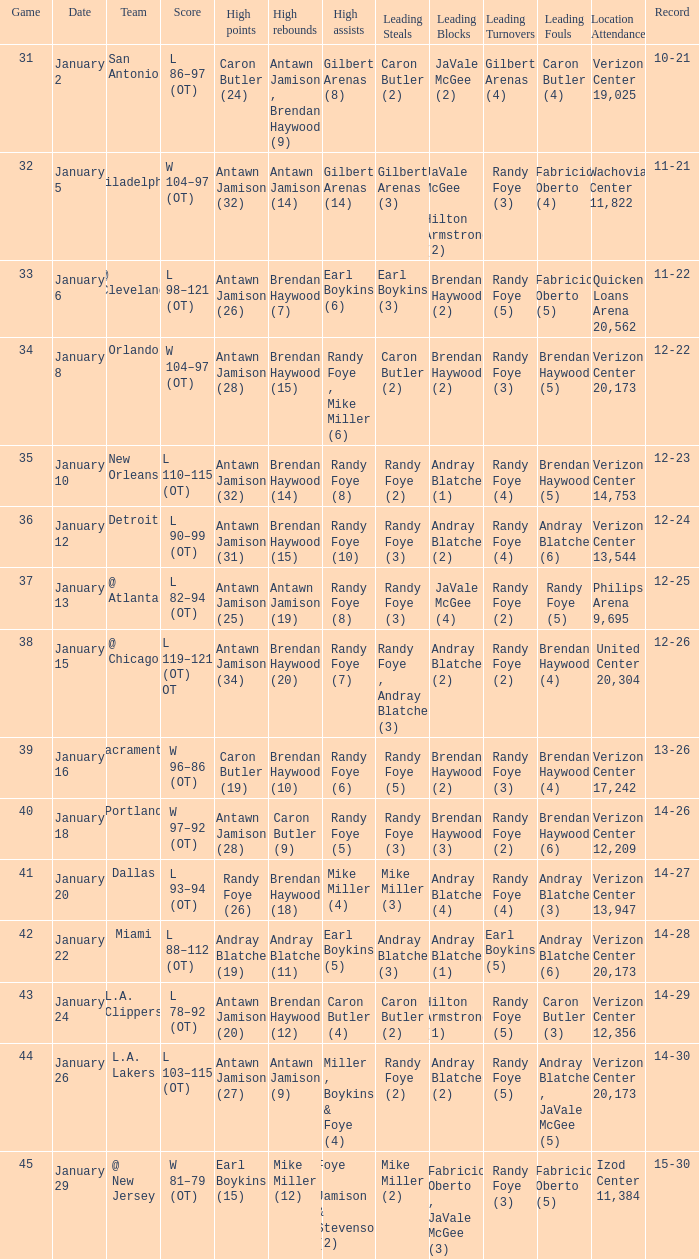What day was the record 14-27? January 20. 